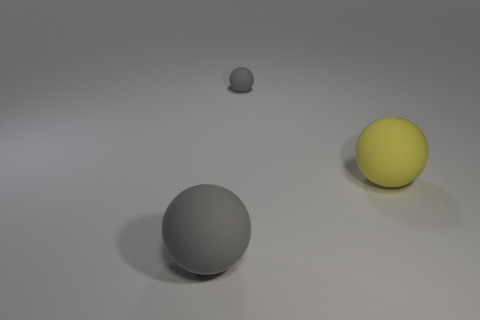What size is the gray matte object behind the big matte ball behind the gray rubber object that is in front of the tiny matte thing?
Offer a terse response. Small. How many other things are the same shape as the large gray object?
Your response must be concise. 2. There is a large gray thing that is the same shape as the small thing; what material is it?
Ensure brevity in your answer.  Rubber. Are there fewer gray rubber balls that are behind the large yellow object than objects?
Offer a very short reply. Yes. What number of large matte objects are to the left of the tiny sphere?
Provide a short and direct response. 1. Is the shape of the rubber thing that is in front of the yellow thing the same as the big yellow object that is right of the tiny gray matte object?
Ensure brevity in your answer.  Yes. What is the shape of the thing that is both on the left side of the big yellow ball and on the right side of the large gray matte object?
Provide a succinct answer. Sphere. What is the size of the other gray ball that is made of the same material as the big gray ball?
Your answer should be very brief. Small. Is the number of tiny rubber spheres less than the number of big purple metal cylinders?
Your answer should be compact. No. There is a matte object that is both left of the yellow sphere and behind the big gray ball; what size is it?
Ensure brevity in your answer.  Small. 